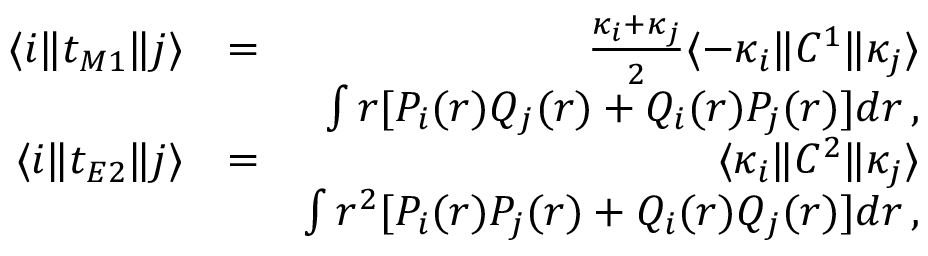<formula> <loc_0><loc_0><loc_500><loc_500>\begin{array} { r l r } { \langle i \| t _ { M 1 } \| j \rangle } & { = } & { \frac { \kappa _ { i } + \kappa _ { j } } { 2 } \langle - \kappa _ { i } \| C ^ { 1 } \| \kappa _ { j } \rangle } \\ & { \int r [ P _ { i } ( r ) Q _ { j } ( r ) + Q _ { i } ( r ) P _ { j } ( r ) ] d r \, , } \\ { \langle i \| t _ { E 2 } \| j \rangle } & { = } & { \langle \kappa _ { i } \| C ^ { 2 } \| \kappa _ { j } \rangle } \\ & { \int r ^ { 2 } [ P _ { i } ( r ) P _ { j } ( r ) + Q _ { i } ( r ) Q _ { j } ( r ) ] d r \, , } \end{array}</formula> 